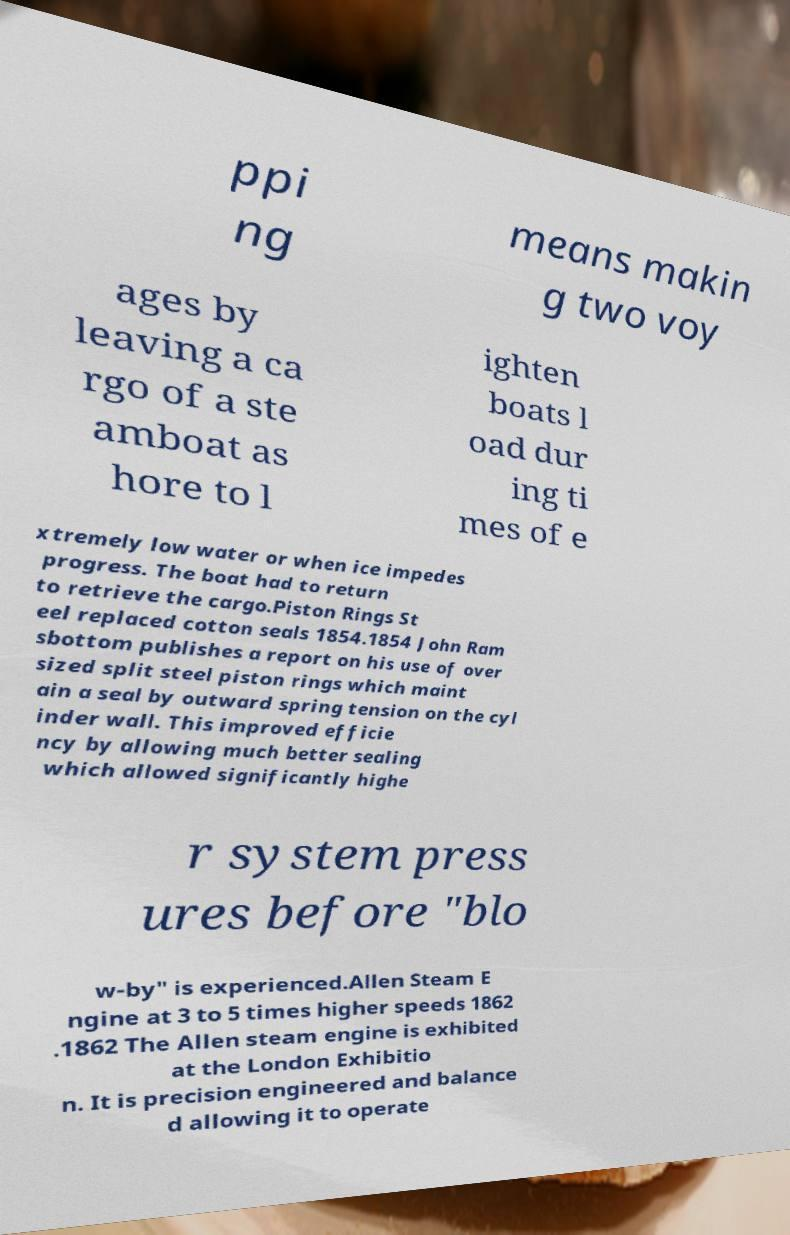Could you extract and type out the text from this image? ppi ng means makin g two voy ages by leaving a ca rgo of a ste amboat as hore to l ighten boats l oad dur ing ti mes of e xtremely low water or when ice impedes progress. The boat had to return to retrieve the cargo.Piston Rings St eel replaced cotton seals 1854.1854 John Ram sbottom publishes a report on his use of over sized split steel piston rings which maint ain a seal by outward spring tension on the cyl inder wall. This improved efficie ncy by allowing much better sealing which allowed significantly highe r system press ures before "blo w-by" is experienced.Allen Steam E ngine at 3 to 5 times higher speeds 1862 .1862 The Allen steam engine is exhibited at the London Exhibitio n. It is precision engineered and balance d allowing it to operate 